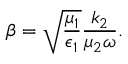Convert formula to latex. <formula><loc_0><loc_0><loc_500><loc_500>\beta = \sqrt { \frac { \mu _ { 1 } } { \epsilon _ { 1 } } } \frac { k _ { 2 } } { \mu _ { 2 } \omega } .</formula> 